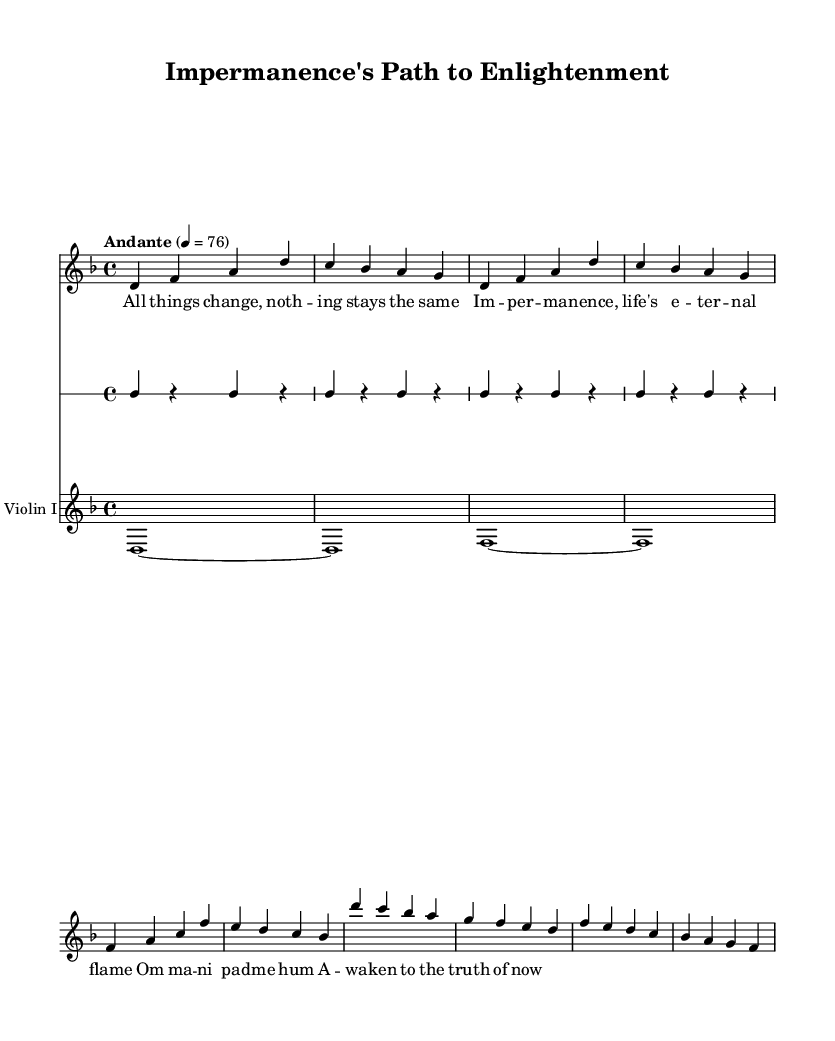What is the key signature of this music? The key signature is D minor, which contains one flat (B flat). This can be determined by looking at the key signature indicated at the beginning of the staff.
Answer: D minor What is the time signature of this piece? The time signature is 4/4, which indicates that there are four beats in each measure and the quarter note receives one beat. This is noted at the beginning of the score near the key signature.
Answer: 4/4 What is the tempo marking of this music? The tempo marking is "Andante," which suggests a moderately slow pace. This is indicated at the start of the score, specifying the intended speed of the piece.
Answer: Andante How many measures are in the verse section? The verse section consists of two measures as seen by the notation which typically may represent one lyrical section or thought. You can identify each measure by the vertical lines dividing them.
Answer: 2 What chant is repeated in the chorus? The chant repeated in the chorus is "Om mani padme hum," a common Buddhist mantra. This phrase is explicitly noted in the lyric section under the corresponding musical notes for the chorus.
Answer: Om mani padme hum What is the instrumental composition present in the score? The instrumental composition includes SATB choir and violin I, as indicated by the labels in the score. The different staffs, with appropriate labels, provide information about the performing forces.
Answer: SATB choir and violin I Which musical element emphasizes the theme of impermanence? The theme of impermanence is emphasized through the repeating phrase "All things change, nothing stays the same," which is directly represented in the lyrics. This evokes the concept of change within the lyrics, embodying the central idea of impermanence in Buddhism.
Answer: Lyrics 